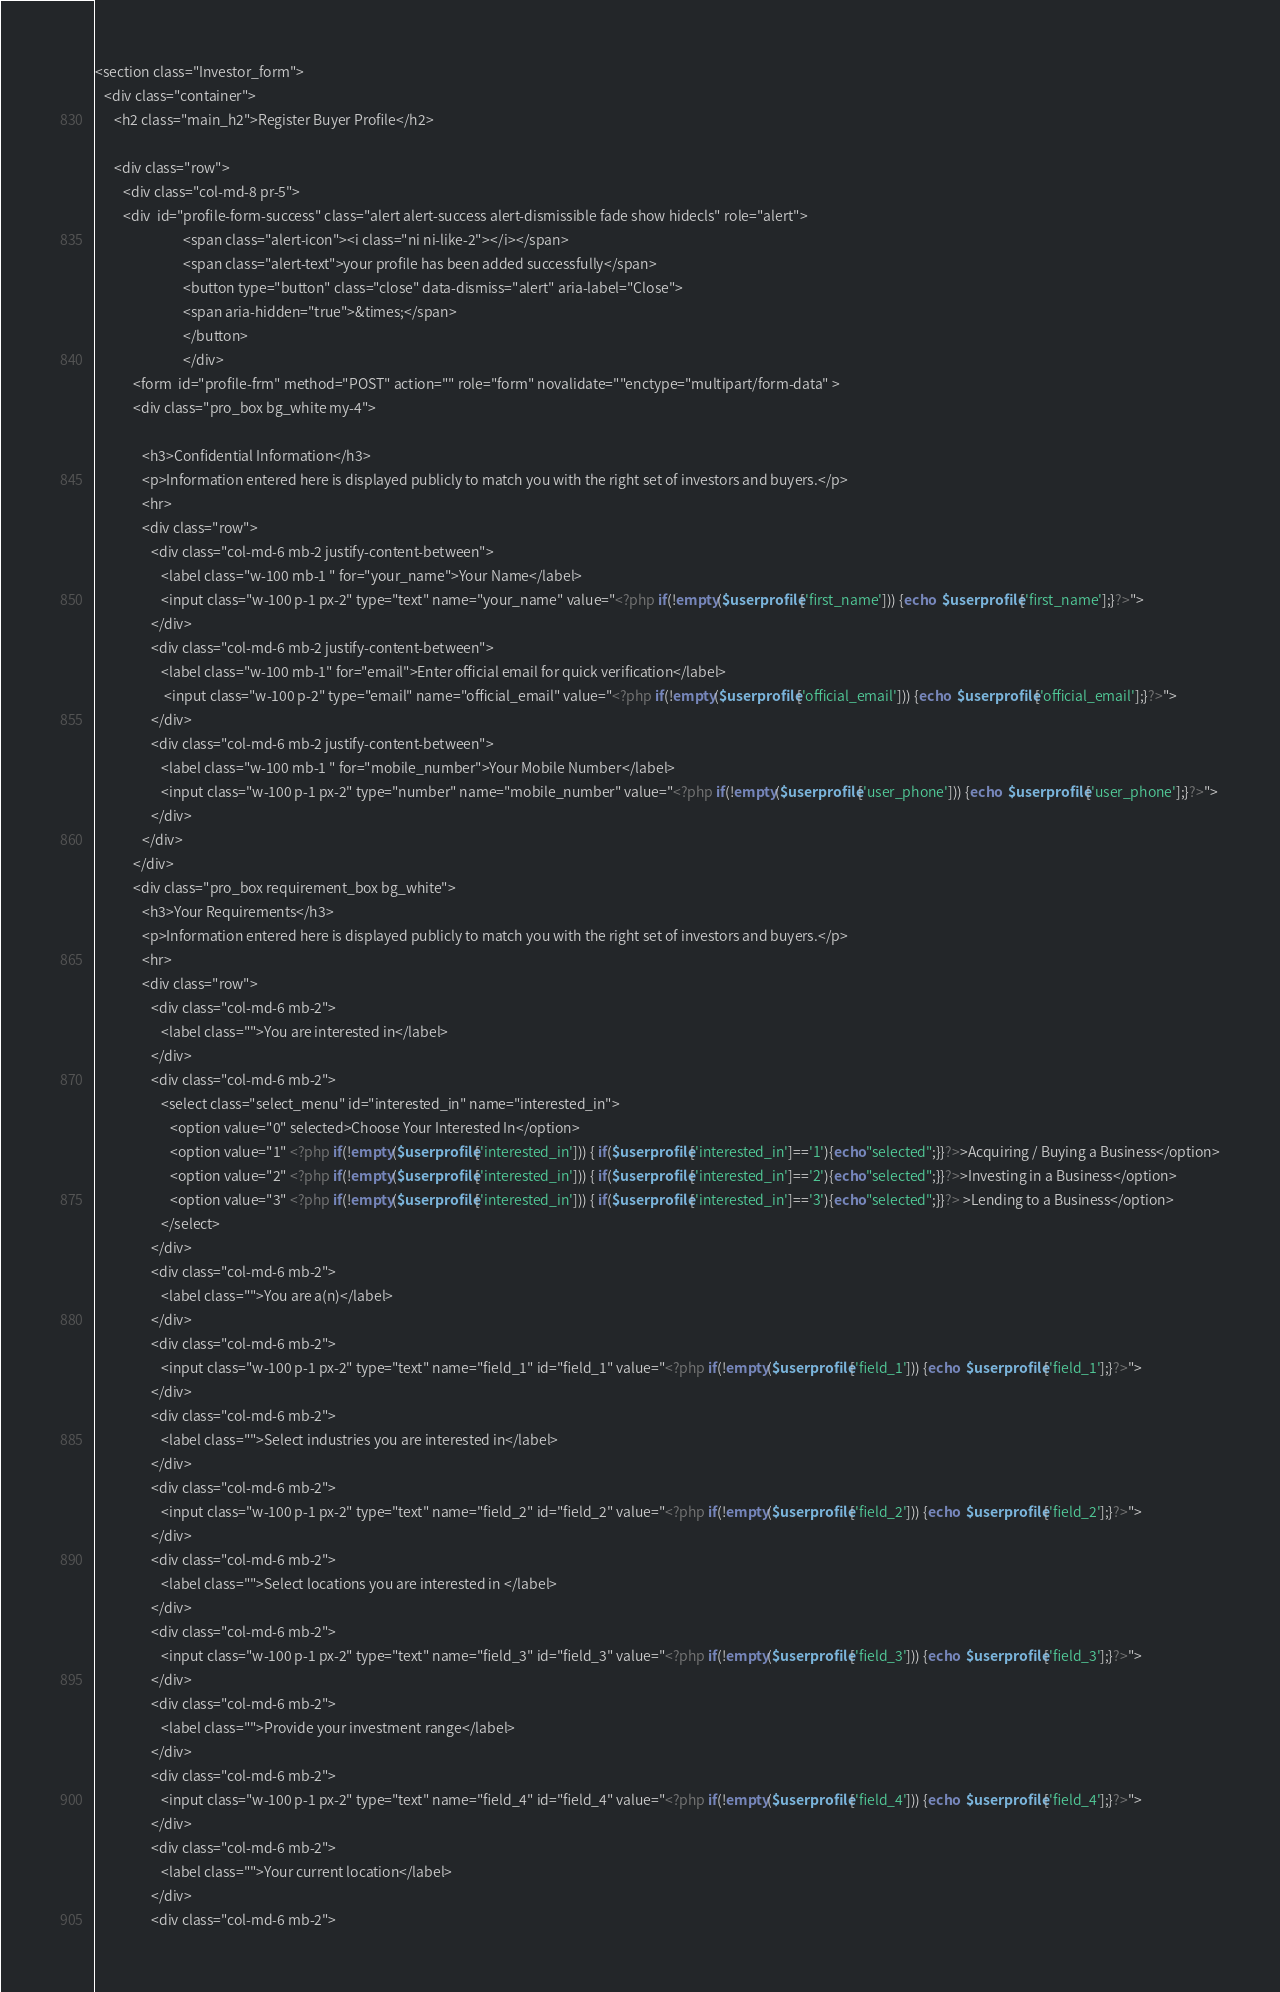<code> <loc_0><loc_0><loc_500><loc_500><_PHP_><section class="Investor_form">
   <div class="container">
      <h2 class="main_h2">Register Buyer Profile</h2>
	    	
      <div class="row">
         <div class="col-md-8 pr-5">
		 <div  id="profile-form-success" class="alert alert-success alert-dismissible fade show hidecls" role="alert">
							<span class="alert-icon"><i class="ni ni-like-2"></i></span>
							<span class="alert-text">your profile has been added successfully</span>
							<button type="button" class="close" data-dismiss="alert" aria-label="Close">
							<span aria-hidden="true">&times;</span>
							</button>
							</div>
			<form  id="profile-frm" method="POST" action="" role="form" novalidate=""enctype="multipart/form-data" >
            <div class="pro_box bg_white my-4">
			
               <h3>Confidential Information</h3>
               <p>Information entered here is displayed publicly to match you with the right set of investors and buyers.</p>
               <hr>
               <div class="row">
                  <div class="col-md-6 mb-2 justify-content-between">
                     <label class="w-100 mb-1 " for="your_name">Your Name</label>
                     <input class="w-100 p-1 px-2" type="text" name="your_name" value="<?php if(!empty($userprofile['first_name'])) {echo  $userprofile['first_name'];}?>">
                  </div>
                  <div class="col-md-6 mb-2 justify-content-between">
                     <label class="w-100 mb-1" for="email">Enter official email for quick verification</label>
                      <input class="w-100 p-2" type="email" name="official_email" value="<?php if(!empty($userprofile['official_email'])) {echo  $userprofile['official_email'];}?>">
                  </div>
                  <div class="col-md-6 mb-2 justify-content-between">
                     <label class="w-100 mb-1 " for="mobile_number">Your Mobile Number</label>
                     <input class="w-100 p-1 px-2" type="number" name="mobile_number" value="<?php if(!empty($userprofile['user_phone'])) {echo  $userprofile['user_phone'];}?>">
                  </div>
               </div>
            </div>
            <div class="pro_box requirement_box bg_white">
               <h3>Your Requirements</h3>
               <p>Information entered here is displayed publicly to match you with the right set of investors and buyers.</p>
               <hr>
               <div class="row">
                  <div class="col-md-6 mb-2">
                     <label class="">You are interested in</label>
                  </div>
                  <div class="col-md-6 mb-2">
                     <select class="select_menu" id="interested_in" name="interested_in">
                        <option value="0" selected>Choose Your Interested In</option>
                        <option value="1" <?php if(!empty($userprofile['interested_in'])) { if($userprofile['interested_in']=='1'){echo"selected";}}?>>Acquiring / Buying a Business</option>
                        <option value="2" <?php if(!empty($userprofile['interested_in'])) { if($userprofile['interested_in']=='2'){echo"selected";}}?>>Investing in a Business</option>
                        <option value="3" <?php if(!empty($userprofile['interested_in'])) { if($userprofile['interested_in']=='3'){echo"selected";}}?> >Lending to a Business</option>
                     </select>
                  </div>
                  <div class="col-md-6 mb-2">
                     <label class="">You are a(n)</label>
                  </div>
                  <div class="col-md-6 mb-2">
                     <input class="w-100 p-1 px-2" type="text" name="field_1" id="field_1" value="<?php if(!empty($userprofile['field_1'])) {echo  $userprofile['field_1'];}?>">
                  </div>
                  <div class="col-md-6 mb-2">
                     <label class="">Select industries you are interested in</label>
                  </div>
                  <div class="col-md-6 mb-2">
                     <input class="w-100 p-1 px-2" type="text" name="field_2" id="field_2" value="<?php if(!empty($userprofile['field_2'])) {echo  $userprofile['field_2'];}?>">
                  </div>
                  <div class="col-md-6 mb-2">
                     <label class="">Select locations you are interested in </label>
                  </div>
                  <div class="col-md-6 mb-2">
                     <input class="w-100 p-1 px-2" type="text" name="field_3" id="field_3" value="<?php if(!empty($userprofile['field_3'])) {echo  $userprofile['field_3'];}?>">
                  </div>
                  <div class="col-md-6 mb-2">
                     <label class="">Provide your investment range</label>
                  </div>
                  <div class="col-md-6 mb-2">
                     <input class="w-100 p-1 px-2" type="text" name="field_4" id="field_4" value="<?php if(!empty($userprofile['field_4'])) {echo  $userprofile['field_4'];}?>">
                  </div>
                  <div class="col-md-6 mb-2">
                     <label class="">Your current location</label>
                  </div>
                  <div class="col-md-6 mb-2"></code> 